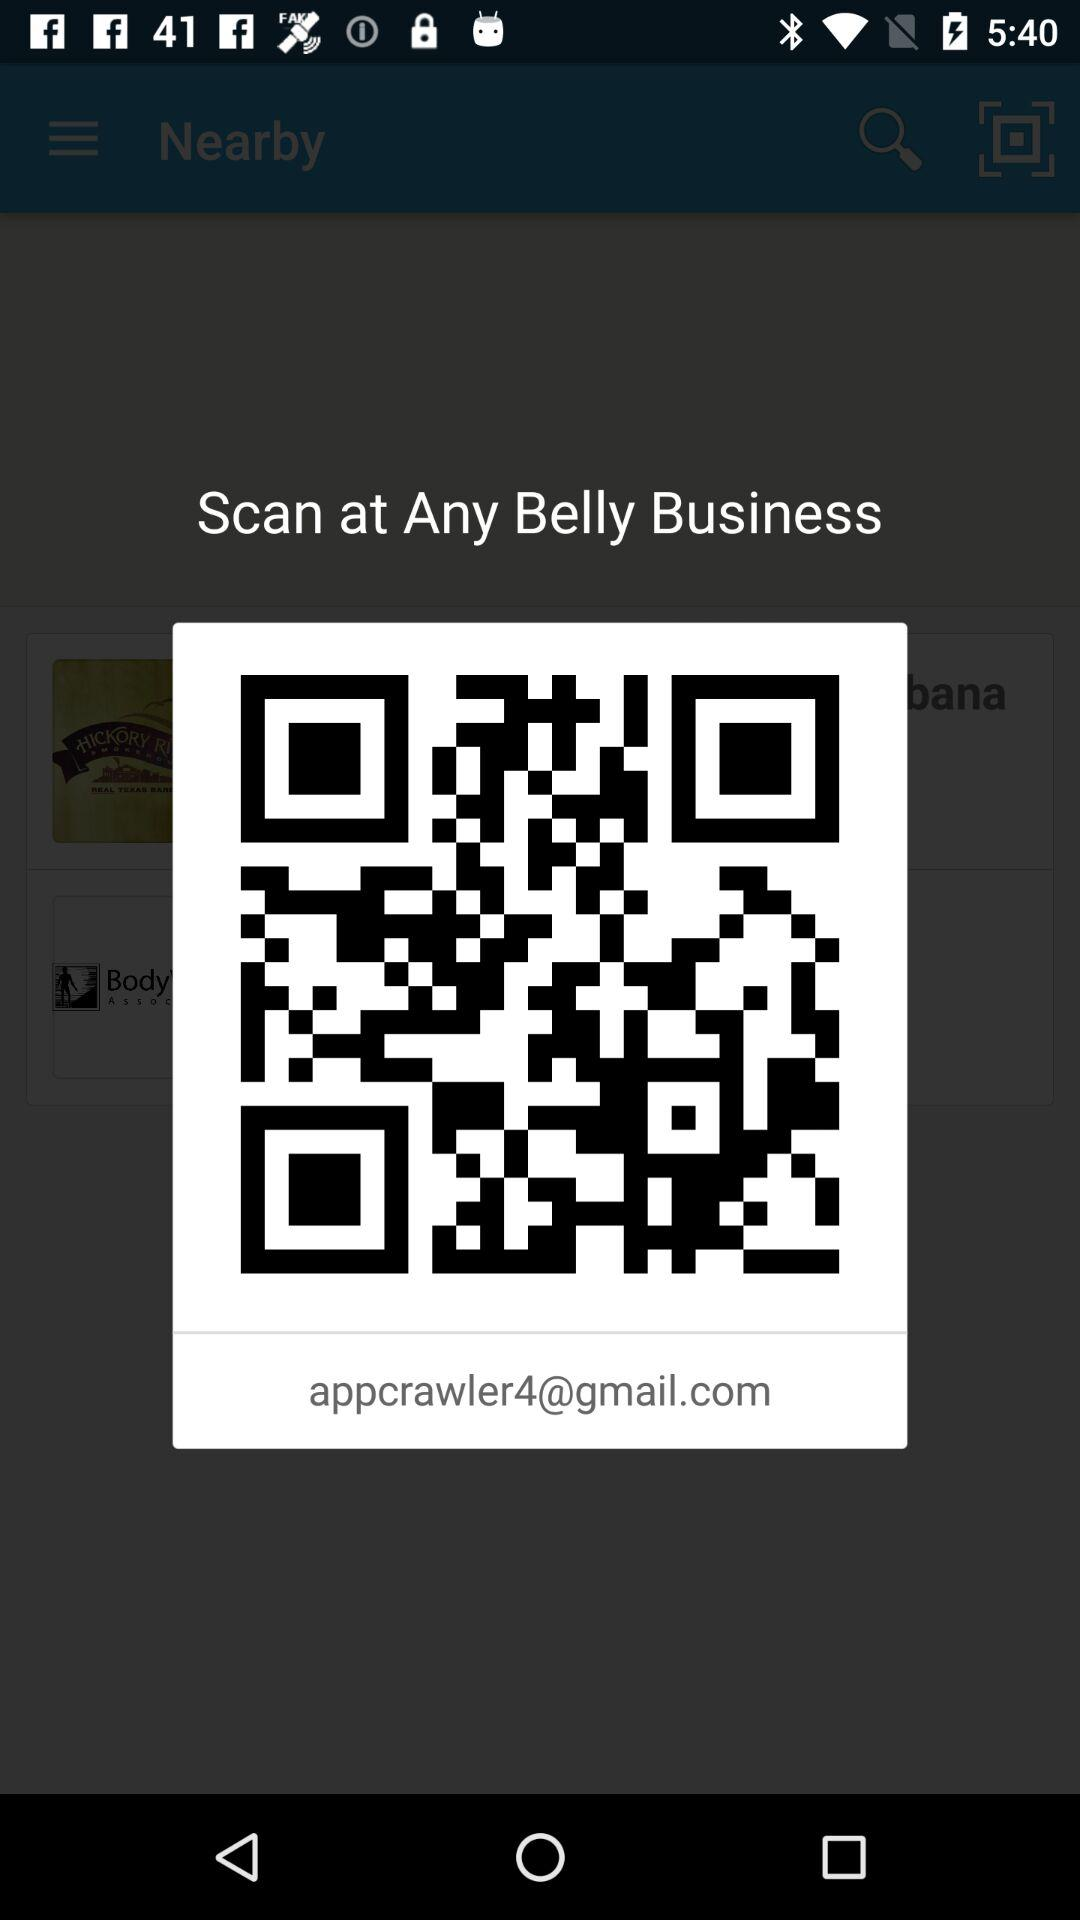What is the given email address? The given email address is appcrawler4@gmail.com. 